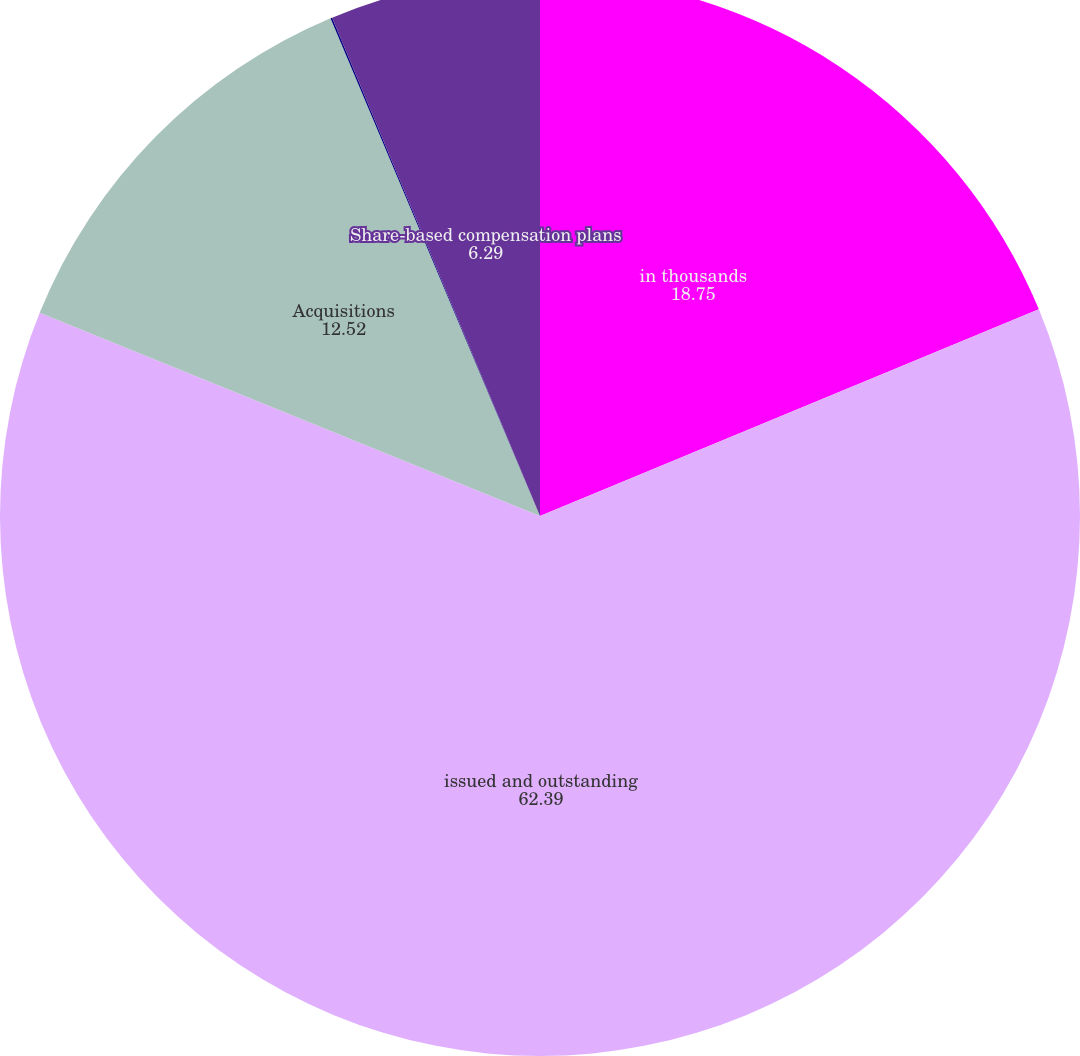<chart> <loc_0><loc_0><loc_500><loc_500><pie_chart><fcel>in thousands<fcel>issued and outstanding<fcel>Acquisitions<fcel>401(k) savings and retirement<fcel>Share-based compensation plans<nl><fcel>18.75%<fcel>62.39%<fcel>12.52%<fcel>0.05%<fcel>6.29%<nl></chart> 